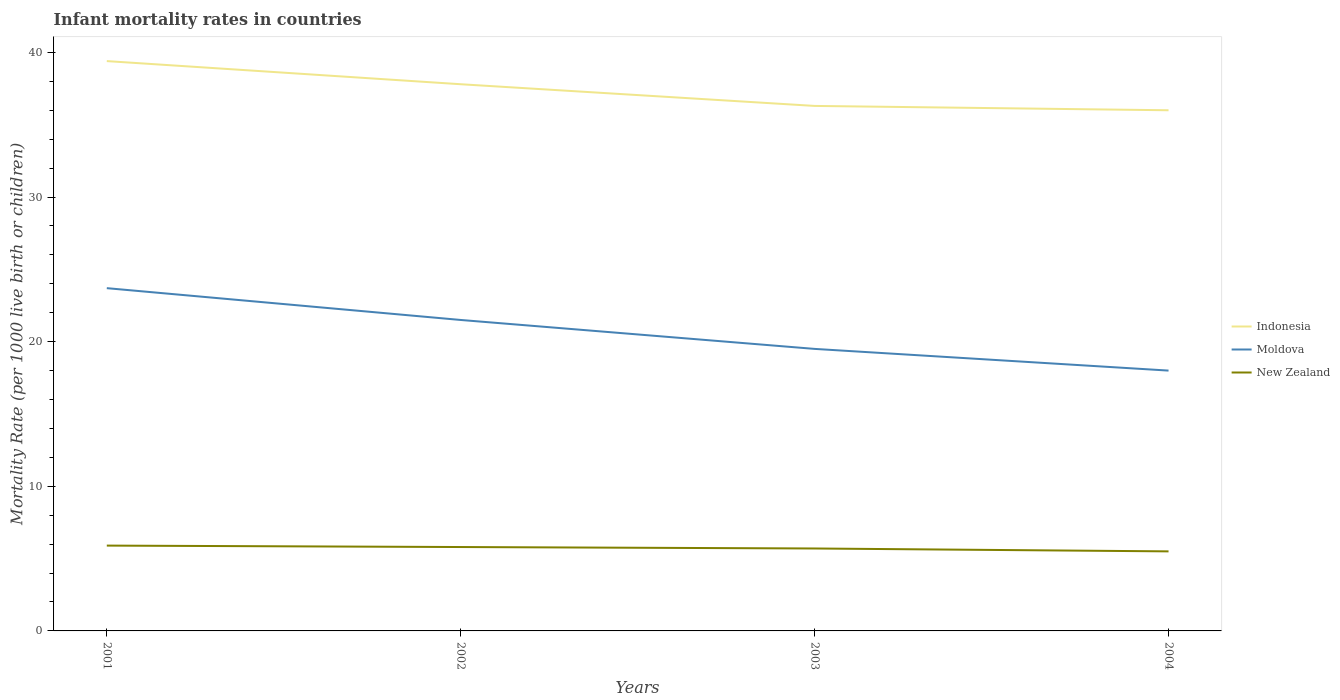How many different coloured lines are there?
Make the answer very short. 3. Is the number of lines equal to the number of legend labels?
Keep it short and to the point. Yes. What is the total infant mortality rate in Indonesia in the graph?
Provide a short and direct response. 1.8. What is the difference between the highest and the second highest infant mortality rate in New Zealand?
Offer a very short reply. 0.4. How many years are there in the graph?
Keep it short and to the point. 4. What is the difference between two consecutive major ticks on the Y-axis?
Keep it short and to the point. 10. Where does the legend appear in the graph?
Provide a succinct answer. Center right. How are the legend labels stacked?
Make the answer very short. Vertical. What is the title of the graph?
Provide a short and direct response. Infant mortality rates in countries. What is the label or title of the X-axis?
Your response must be concise. Years. What is the label or title of the Y-axis?
Give a very brief answer. Mortality Rate (per 1000 live birth or children). What is the Mortality Rate (per 1000 live birth or children) in Indonesia in 2001?
Your answer should be very brief. 39.4. What is the Mortality Rate (per 1000 live birth or children) in Moldova in 2001?
Provide a short and direct response. 23.7. What is the Mortality Rate (per 1000 live birth or children) in Indonesia in 2002?
Give a very brief answer. 37.8. What is the Mortality Rate (per 1000 live birth or children) of Moldova in 2002?
Your response must be concise. 21.5. What is the Mortality Rate (per 1000 live birth or children) in Indonesia in 2003?
Make the answer very short. 36.3. What is the Mortality Rate (per 1000 live birth or children) in Moldova in 2003?
Offer a terse response. 19.5. What is the Mortality Rate (per 1000 live birth or children) in New Zealand in 2003?
Your answer should be compact. 5.7. What is the Mortality Rate (per 1000 live birth or children) of Moldova in 2004?
Offer a terse response. 18. What is the Mortality Rate (per 1000 live birth or children) of New Zealand in 2004?
Provide a short and direct response. 5.5. Across all years, what is the maximum Mortality Rate (per 1000 live birth or children) of Indonesia?
Give a very brief answer. 39.4. Across all years, what is the maximum Mortality Rate (per 1000 live birth or children) of Moldova?
Your answer should be very brief. 23.7. Across all years, what is the minimum Mortality Rate (per 1000 live birth or children) of Moldova?
Keep it short and to the point. 18. What is the total Mortality Rate (per 1000 live birth or children) in Indonesia in the graph?
Provide a succinct answer. 149.5. What is the total Mortality Rate (per 1000 live birth or children) of Moldova in the graph?
Ensure brevity in your answer.  82.7. What is the total Mortality Rate (per 1000 live birth or children) in New Zealand in the graph?
Provide a succinct answer. 22.9. What is the difference between the Mortality Rate (per 1000 live birth or children) of New Zealand in 2001 and that in 2003?
Provide a succinct answer. 0.2. What is the difference between the Mortality Rate (per 1000 live birth or children) of Indonesia in 2002 and that in 2003?
Give a very brief answer. 1.5. What is the difference between the Mortality Rate (per 1000 live birth or children) of Indonesia in 2002 and that in 2004?
Offer a terse response. 1.8. What is the difference between the Mortality Rate (per 1000 live birth or children) in Moldova in 2002 and that in 2004?
Provide a short and direct response. 3.5. What is the difference between the Mortality Rate (per 1000 live birth or children) in New Zealand in 2002 and that in 2004?
Give a very brief answer. 0.3. What is the difference between the Mortality Rate (per 1000 live birth or children) in Indonesia in 2003 and that in 2004?
Offer a terse response. 0.3. What is the difference between the Mortality Rate (per 1000 live birth or children) in Moldova in 2003 and that in 2004?
Offer a very short reply. 1.5. What is the difference between the Mortality Rate (per 1000 live birth or children) of Indonesia in 2001 and the Mortality Rate (per 1000 live birth or children) of Moldova in 2002?
Ensure brevity in your answer.  17.9. What is the difference between the Mortality Rate (per 1000 live birth or children) in Indonesia in 2001 and the Mortality Rate (per 1000 live birth or children) in New Zealand in 2002?
Provide a succinct answer. 33.6. What is the difference between the Mortality Rate (per 1000 live birth or children) of Indonesia in 2001 and the Mortality Rate (per 1000 live birth or children) of New Zealand in 2003?
Your answer should be compact. 33.7. What is the difference between the Mortality Rate (per 1000 live birth or children) in Indonesia in 2001 and the Mortality Rate (per 1000 live birth or children) in Moldova in 2004?
Provide a short and direct response. 21.4. What is the difference between the Mortality Rate (per 1000 live birth or children) in Indonesia in 2001 and the Mortality Rate (per 1000 live birth or children) in New Zealand in 2004?
Give a very brief answer. 33.9. What is the difference between the Mortality Rate (per 1000 live birth or children) in Indonesia in 2002 and the Mortality Rate (per 1000 live birth or children) in New Zealand in 2003?
Provide a succinct answer. 32.1. What is the difference between the Mortality Rate (per 1000 live birth or children) of Moldova in 2002 and the Mortality Rate (per 1000 live birth or children) of New Zealand in 2003?
Offer a very short reply. 15.8. What is the difference between the Mortality Rate (per 1000 live birth or children) of Indonesia in 2002 and the Mortality Rate (per 1000 live birth or children) of Moldova in 2004?
Your answer should be very brief. 19.8. What is the difference between the Mortality Rate (per 1000 live birth or children) in Indonesia in 2002 and the Mortality Rate (per 1000 live birth or children) in New Zealand in 2004?
Ensure brevity in your answer.  32.3. What is the difference between the Mortality Rate (per 1000 live birth or children) in Moldova in 2002 and the Mortality Rate (per 1000 live birth or children) in New Zealand in 2004?
Offer a terse response. 16. What is the difference between the Mortality Rate (per 1000 live birth or children) in Indonesia in 2003 and the Mortality Rate (per 1000 live birth or children) in New Zealand in 2004?
Give a very brief answer. 30.8. What is the average Mortality Rate (per 1000 live birth or children) of Indonesia per year?
Keep it short and to the point. 37.38. What is the average Mortality Rate (per 1000 live birth or children) in Moldova per year?
Ensure brevity in your answer.  20.68. What is the average Mortality Rate (per 1000 live birth or children) of New Zealand per year?
Your answer should be compact. 5.72. In the year 2001, what is the difference between the Mortality Rate (per 1000 live birth or children) in Indonesia and Mortality Rate (per 1000 live birth or children) in Moldova?
Give a very brief answer. 15.7. In the year 2001, what is the difference between the Mortality Rate (per 1000 live birth or children) in Indonesia and Mortality Rate (per 1000 live birth or children) in New Zealand?
Offer a very short reply. 33.5. In the year 2001, what is the difference between the Mortality Rate (per 1000 live birth or children) of Moldova and Mortality Rate (per 1000 live birth or children) of New Zealand?
Offer a terse response. 17.8. In the year 2003, what is the difference between the Mortality Rate (per 1000 live birth or children) of Indonesia and Mortality Rate (per 1000 live birth or children) of Moldova?
Provide a short and direct response. 16.8. In the year 2003, what is the difference between the Mortality Rate (per 1000 live birth or children) of Indonesia and Mortality Rate (per 1000 live birth or children) of New Zealand?
Your answer should be very brief. 30.6. In the year 2004, what is the difference between the Mortality Rate (per 1000 live birth or children) in Indonesia and Mortality Rate (per 1000 live birth or children) in New Zealand?
Offer a terse response. 30.5. In the year 2004, what is the difference between the Mortality Rate (per 1000 live birth or children) of Moldova and Mortality Rate (per 1000 live birth or children) of New Zealand?
Make the answer very short. 12.5. What is the ratio of the Mortality Rate (per 1000 live birth or children) of Indonesia in 2001 to that in 2002?
Ensure brevity in your answer.  1.04. What is the ratio of the Mortality Rate (per 1000 live birth or children) in Moldova in 2001 to that in 2002?
Make the answer very short. 1.1. What is the ratio of the Mortality Rate (per 1000 live birth or children) of New Zealand in 2001 to that in 2002?
Give a very brief answer. 1.02. What is the ratio of the Mortality Rate (per 1000 live birth or children) of Indonesia in 2001 to that in 2003?
Ensure brevity in your answer.  1.09. What is the ratio of the Mortality Rate (per 1000 live birth or children) in Moldova in 2001 to that in 2003?
Give a very brief answer. 1.22. What is the ratio of the Mortality Rate (per 1000 live birth or children) of New Zealand in 2001 to that in 2003?
Offer a terse response. 1.04. What is the ratio of the Mortality Rate (per 1000 live birth or children) in Indonesia in 2001 to that in 2004?
Provide a short and direct response. 1.09. What is the ratio of the Mortality Rate (per 1000 live birth or children) in Moldova in 2001 to that in 2004?
Make the answer very short. 1.32. What is the ratio of the Mortality Rate (per 1000 live birth or children) of New Zealand in 2001 to that in 2004?
Provide a short and direct response. 1.07. What is the ratio of the Mortality Rate (per 1000 live birth or children) of Indonesia in 2002 to that in 2003?
Offer a very short reply. 1.04. What is the ratio of the Mortality Rate (per 1000 live birth or children) in Moldova in 2002 to that in 2003?
Offer a very short reply. 1.1. What is the ratio of the Mortality Rate (per 1000 live birth or children) in New Zealand in 2002 to that in 2003?
Ensure brevity in your answer.  1.02. What is the ratio of the Mortality Rate (per 1000 live birth or children) in Indonesia in 2002 to that in 2004?
Your answer should be very brief. 1.05. What is the ratio of the Mortality Rate (per 1000 live birth or children) of Moldova in 2002 to that in 2004?
Give a very brief answer. 1.19. What is the ratio of the Mortality Rate (per 1000 live birth or children) of New Zealand in 2002 to that in 2004?
Your response must be concise. 1.05. What is the ratio of the Mortality Rate (per 1000 live birth or children) of Indonesia in 2003 to that in 2004?
Provide a succinct answer. 1.01. What is the ratio of the Mortality Rate (per 1000 live birth or children) in New Zealand in 2003 to that in 2004?
Provide a succinct answer. 1.04. What is the difference between the highest and the lowest Mortality Rate (per 1000 live birth or children) of New Zealand?
Provide a succinct answer. 0.4. 